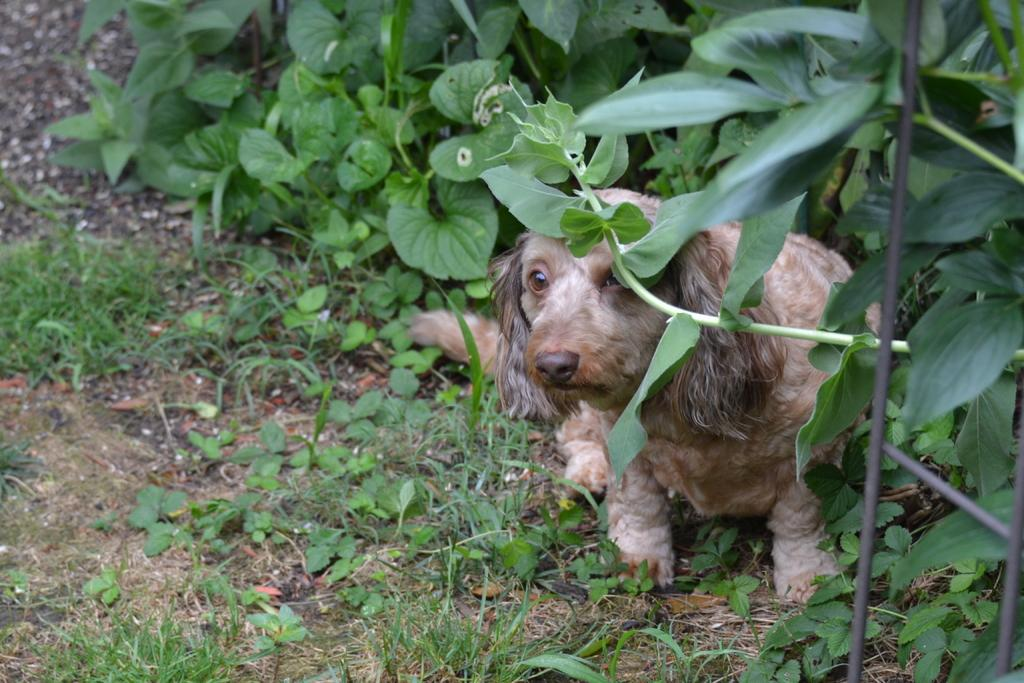What animal is sitting in the image? There is a dog sitting in the image. What type of vegetation can be seen in the image? There are plants in the image. What type of ground surface is visible in the image? There is grass visible in the image. What part of the dog is reciting prose in the image? Dogs do not recite prose, and there is no indication in the image that any part of the dog is doing so. 